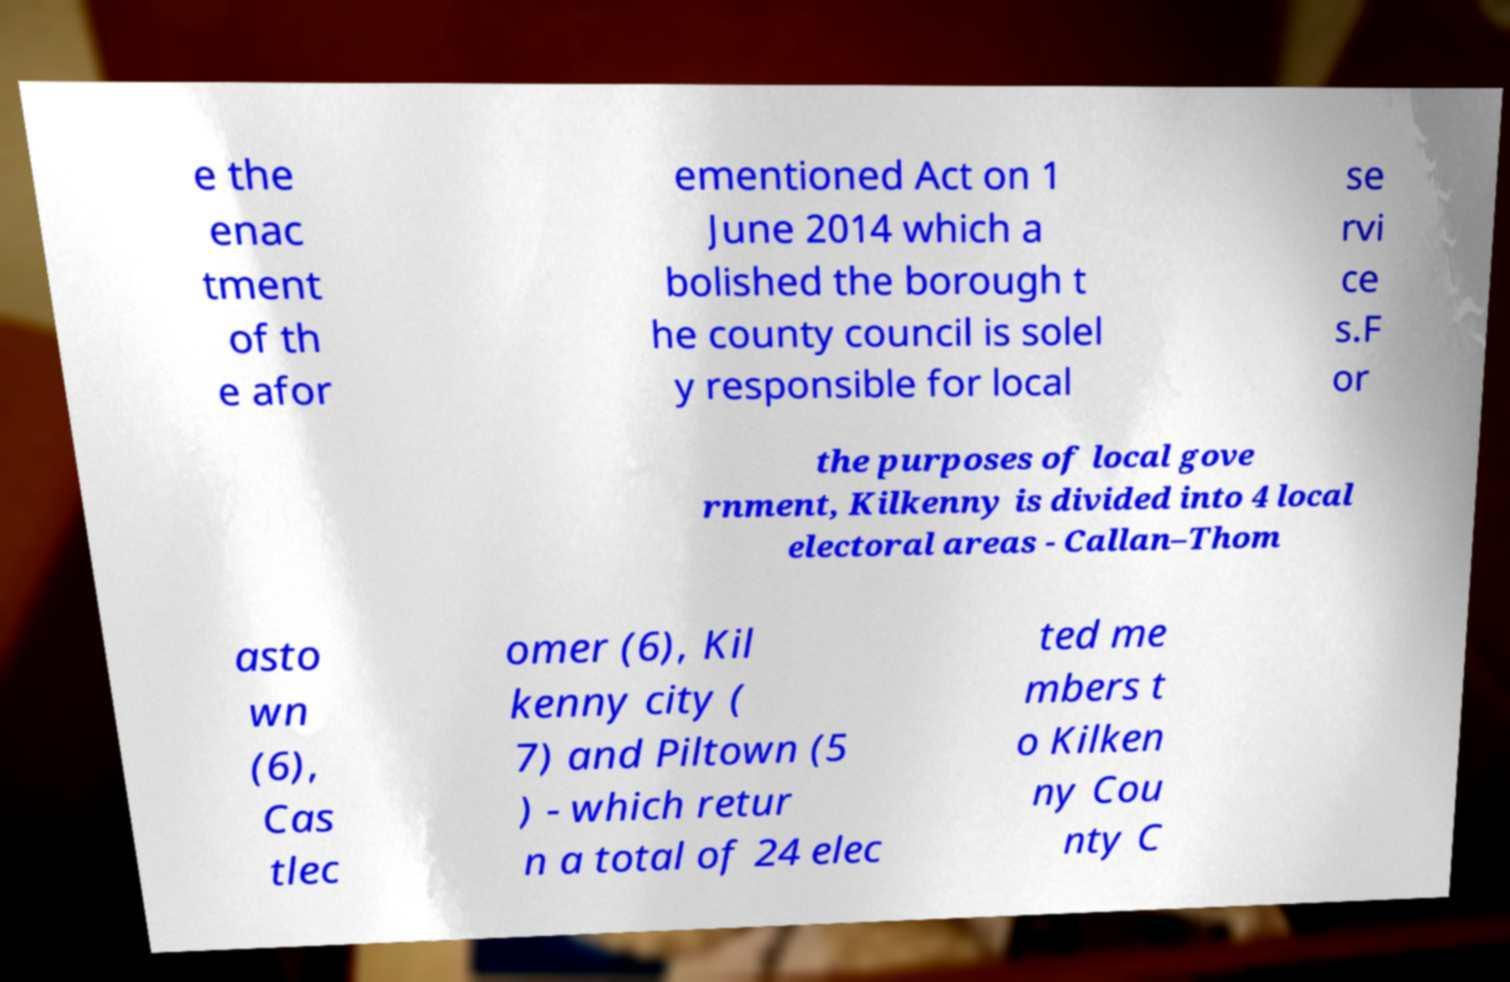Can you accurately transcribe the text from the provided image for me? e the enac tment of th e afor ementioned Act on 1 June 2014 which a bolished the borough t he county council is solel y responsible for local se rvi ce s.F or the purposes of local gove rnment, Kilkenny is divided into 4 local electoral areas - Callan–Thom asto wn (6), Cas tlec omer (6), Kil kenny city ( 7) and Piltown (5 ) - which retur n a total of 24 elec ted me mbers t o Kilken ny Cou nty C 